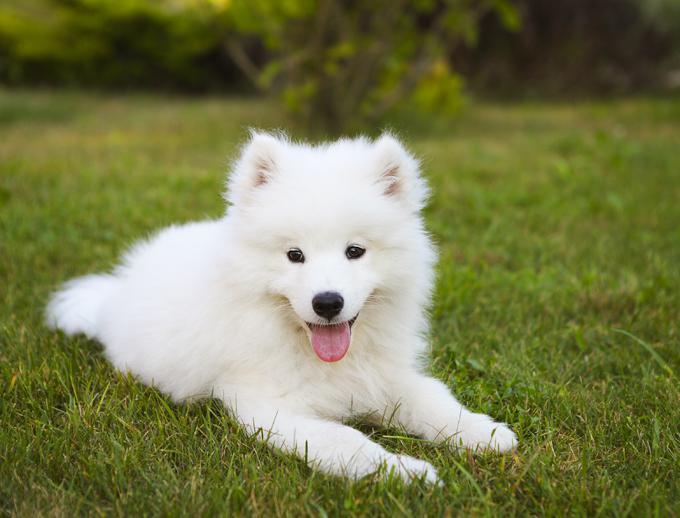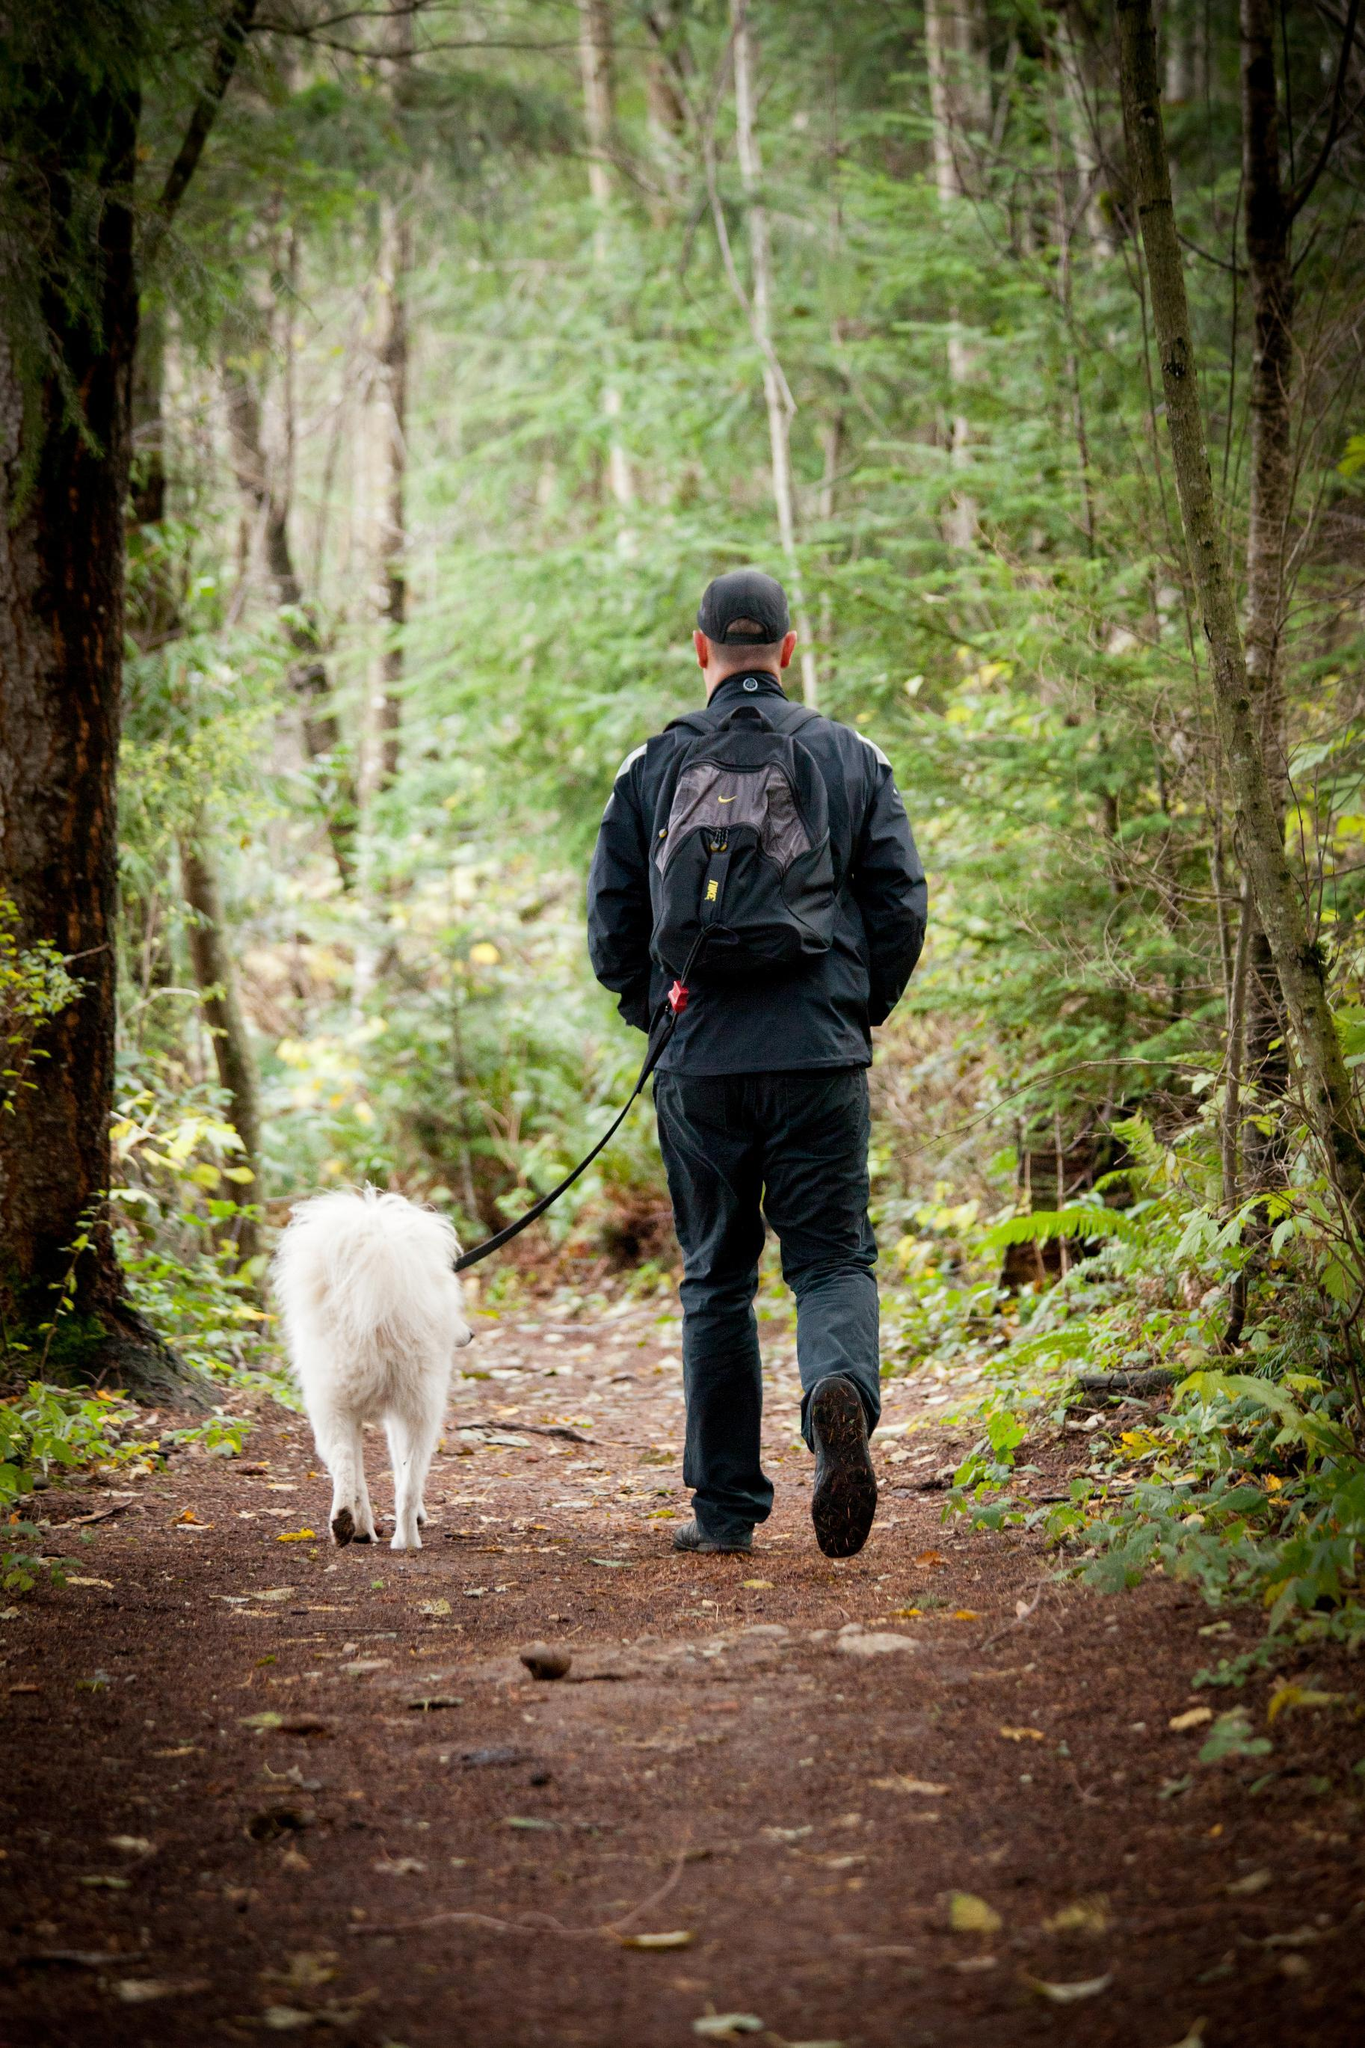The first image is the image on the left, the second image is the image on the right. Evaluate the accuracy of this statement regarding the images: "there is a dog wearing a back pack". Is it true? Answer yes or no. No. 